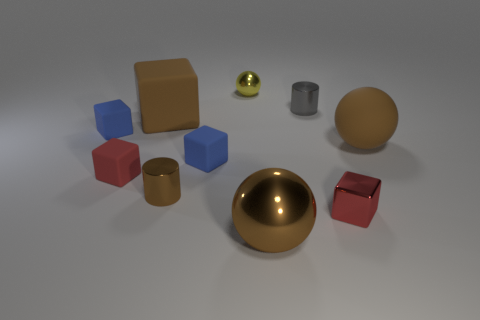What size is the other block that is the same color as the metal block?
Give a very brief answer. Small. Is the shape of the brown rubber thing that is on the right side of the yellow shiny ball the same as  the small yellow thing?
Ensure brevity in your answer.  Yes. Are there more large balls that are behind the matte sphere than small red objects that are behind the brown rubber block?
Keep it short and to the point. No. How many small gray cylinders are in front of the brown metal object behind the large brown metal thing?
Your response must be concise. 0. There is a small object that is the same color as the large rubber block; what material is it?
Your response must be concise. Metal. What number of other things are there of the same color as the rubber ball?
Your answer should be very brief. 3. There is a tiny cylinder that is in front of the small cylinder on the right side of the brown cylinder; what is its color?
Offer a very short reply. Brown. Is there a tiny matte thing that has the same color as the large metal object?
Give a very brief answer. No. What number of matte things are tiny blue blocks or big brown spheres?
Your answer should be very brief. 3. Is there a small sphere made of the same material as the small gray object?
Give a very brief answer. Yes. 